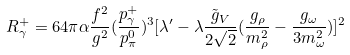<formula> <loc_0><loc_0><loc_500><loc_500>R _ { \gamma } ^ { + } = 6 4 \pi \alpha \frac { f ^ { 2 } } { g ^ { 2 } } ( \frac { p _ { \gamma } ^ { + } } { p _ { \pi } ^ { 0 } } ) ^ { 3 } [ \lambda ^ { \prime } - \lambda \frac { { \tilde { g } } _ { V } } { 2 { \sqrt { 2 } } } ( \frac { g _ { \rho } } { m _ { \rho } ^ { 2 } } - \frac { g _ { \omega } } { 3 m _ { \omega } ^ { 2 } } ) ] ^ { 2 }</formula> 